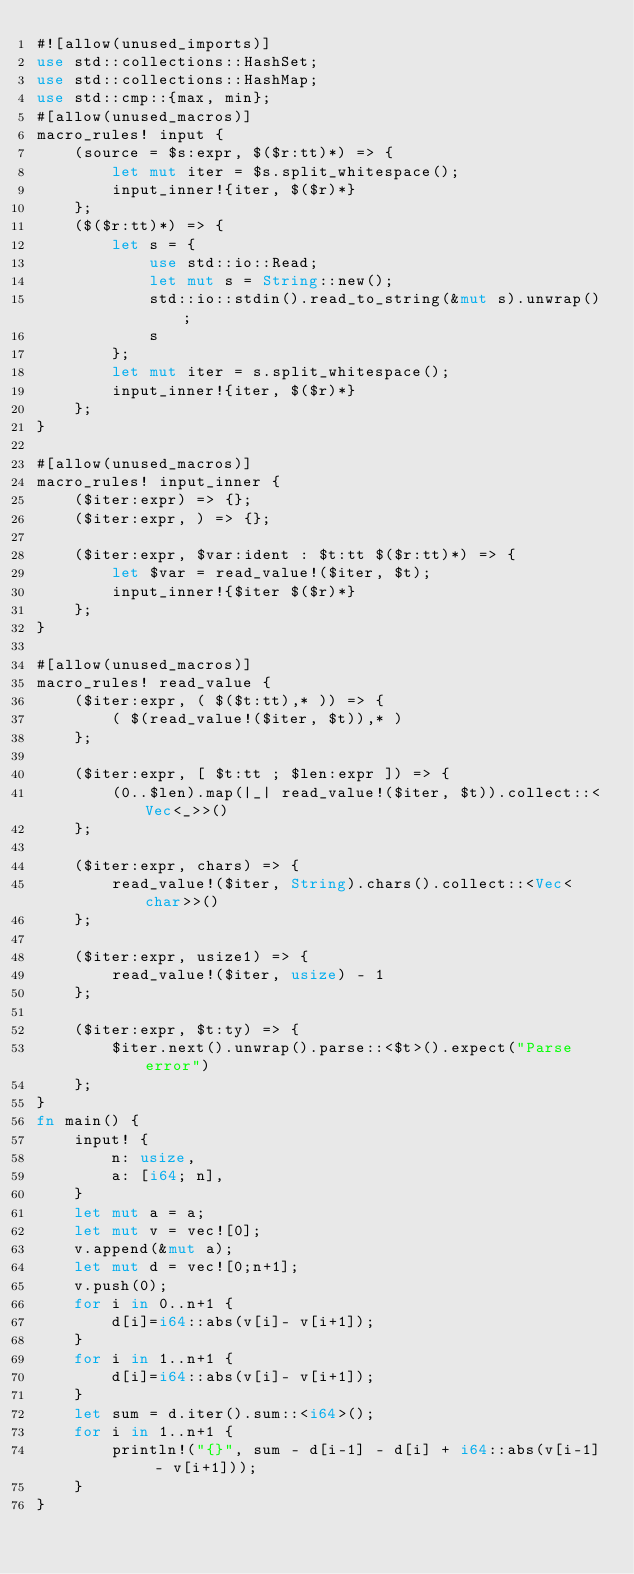Convert code to text. <code><loc_0><loc_0><loc_500><loc_500><_Rust_>#![allow(unused_imports)]
use std::collections::HashSet;
use std::collections::HashMap;
use std::cmp::{max, min};
#[allow(unused_macros)]
macro_rules! input {
    (source = $s:expr, $($r:tt)*) => {
        let mut iter = $s.split_whitespace();
        input_inner!{iter, $($r)*}
    };
    ($($r:tt)*) => {
        let s = {
            use std::io::Read;
            let mut s = String::new();
            std::io::stdin().read_to_string(&mut s).unwrap();
            s
        };
        let mut iter = s.split_whitespace();
        input_inner!{iter, $($r)*}
    };
}

#[allow(unused_macros)]
macro_rules! input_inner {
    ($iter:expr) => {};
    ($iter:expr, ) => {};

    ($iter:expr, $var:ident : $t:tt $($r:tt)*) => {
        let $var = read_value!($iter, $t);
        input_inner!{$iter $($r)*}
    };
}

#[allow(unused_macros)]
macro_rules! read_value {
    ($iter:expr, ( $($t:tt),* )) => {
        ( $(read_value!($iter, $t)),* )
    };

    ($iter:expr, [ $t:tt ; $len:expr ]) => {
        (0..$len).map(|_| read_value!($iter, $t)).collect::<Vec<_>>()
    };

    ($iter:expr, chars) => {
        read_value!($iter, String).chars().collect::<Vec<char>>()
    };

    ($iter:expr, usize1) => {
        read_value!($iter, usize) - 1
    };

    ($iter:expr, $t:ty) => {
        $iter.next().unwrap().parse::<$t>().expect("Parse error")
    };
}
fn main() {
    input! {
        n: usize,
        a: [i64; n],
    }
    let mut a = a;
    let mut v = vec![0];
    v.append(&mut a);
    let mut d = vec![0;n+1];
    v.push(0);
    for i in 0..n+1 {
        d[i]=i64::abs(v[i]- v[i+1]);
    }
    for i in 1..n+1 {
        d[i]=i64::abs(v[i]- v[i+1]);
    }
    let sum = d.iter().sum::<i64>();
    for i in 1..n+1 {
        println!("{}", sum - d[i-1] - d[i] + i64::abs(v[i-1] - v[i+1]));
    }
}</code> 